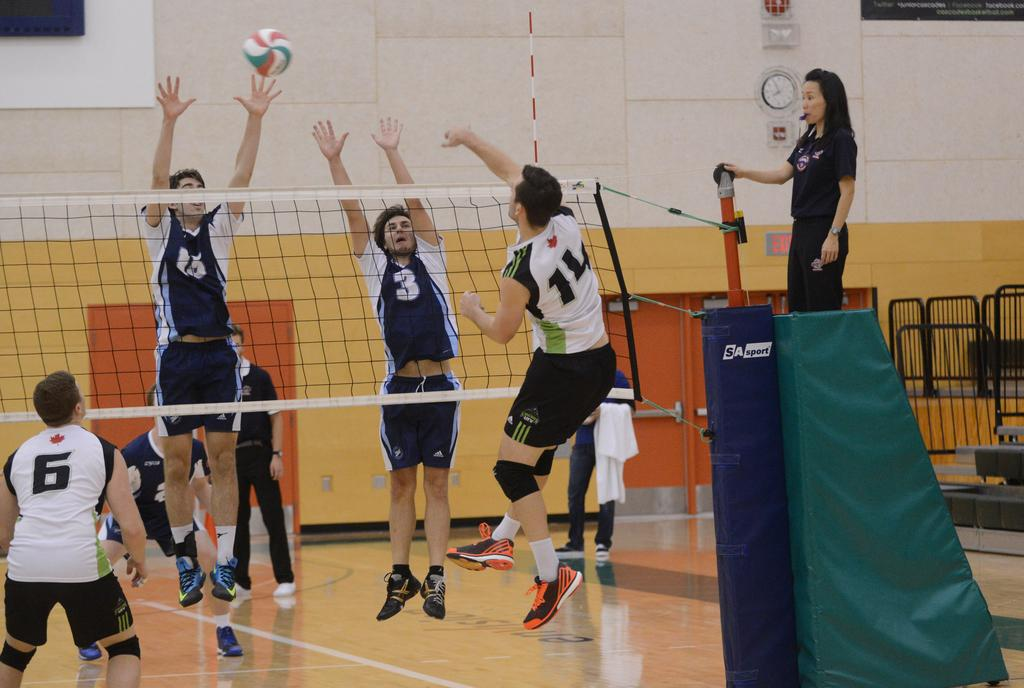Provide a one-sentence caption for the provided image. A female referee watches over a game where player number 3 jumps for the volleyball. 